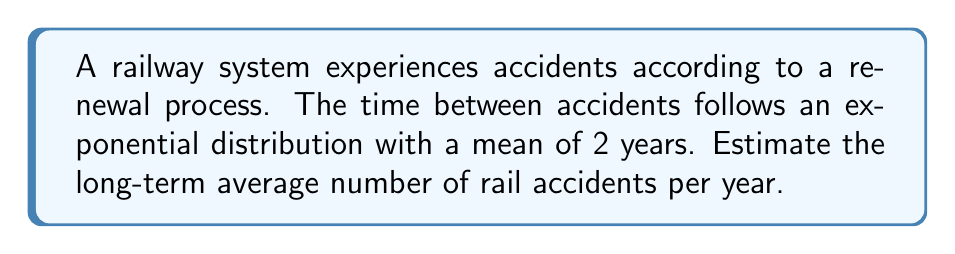Give your solution to this math problem. To solve this problem, we'll follow these steps:

1) In a renewal process, the long-term average number of events per unit time is given by the reciprocal of the mean inter-event time. This is known as the renewal function's asymptotic behavior.

2) Let $\lambda$ be the rate parameter of the exponential distribution. We know that for an exponential distribution:

   $E[X] = \frac{1}{\lambda}$

   where $E[X]$ is the mean of the distribution.

3) We're given that the mean time between accidents is 2 years. Therefore:

   $2 = \frac{1}{\lambda}$

4) Solving for $\lambda$:

   $\lambda = \frac{1}{2}$ per year

5) The long-term average number of events per year is equal to $\lambda$. Therefore, the long-term average number of accidents per year is $\frac{1}{2}$ or 0.5.

This result aligns with intuition: if accidents occur on average every 2 years, we would expect 0.5 accidents per year in the long run.
Answer: 0.5 accidents per year 